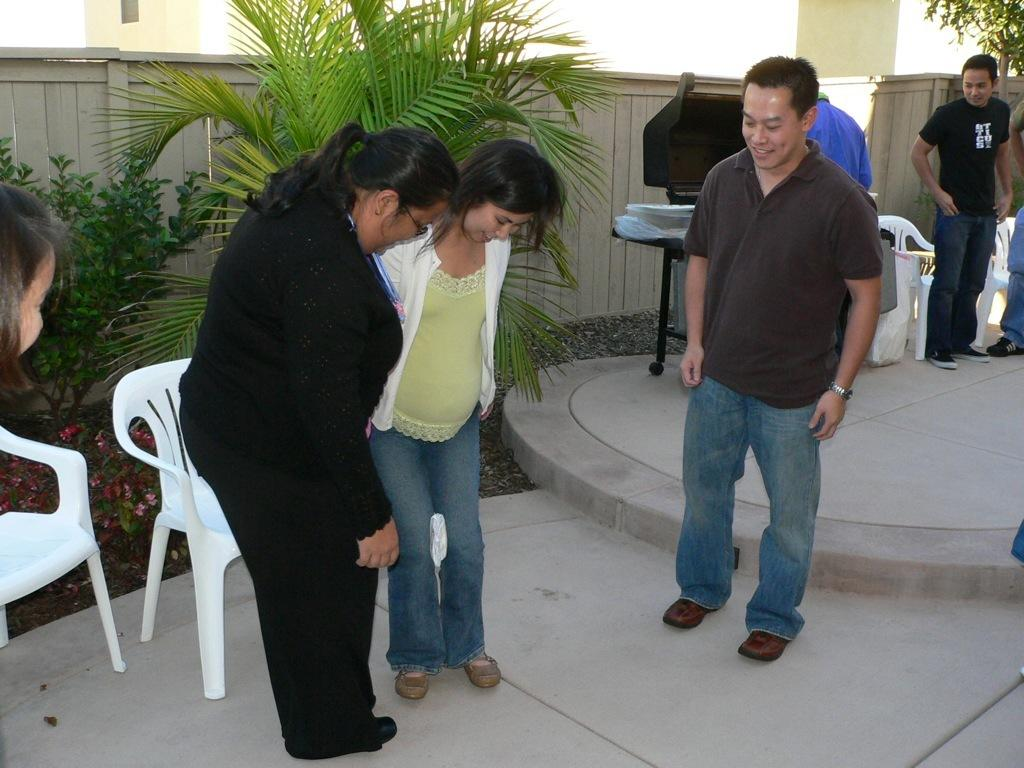Who is present in the image? There are men and women standing in the image. What is the surface they are standing on? They are standing on the floor. What can be seen in the background of the image? There is a wooden fence, buildings, shrubs, plants, and chairs in the background of the image. What type of yoke is being used by the sister in the image? There is no sister present in the image, and no yoke is visible. 